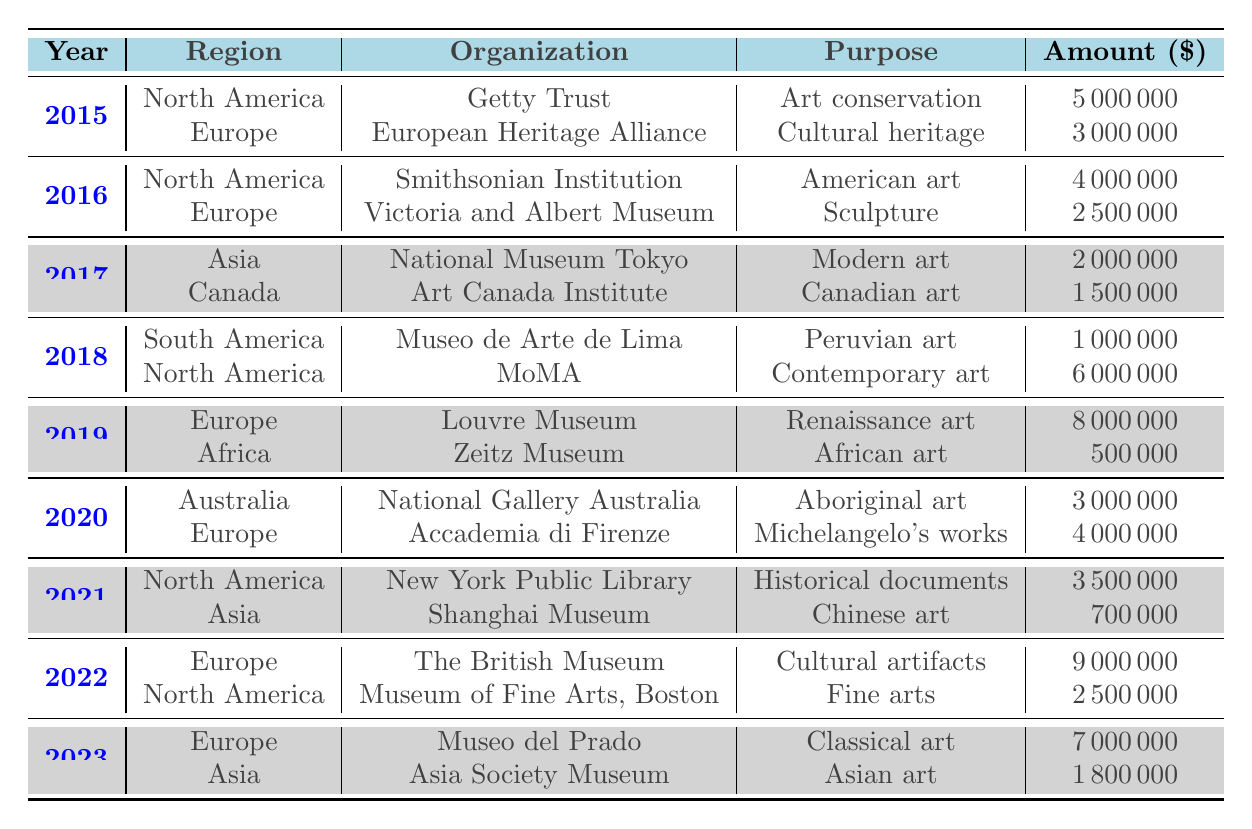What was the total amount donated in 2019? From the table, the donations in 2019 were made to the Louvre Museum for 8,000,000 and to the Zeitz Museum for 500,000. Adding these amounts gives 8,000,000 + 500,000 = 8,500,000.
Answer: 8,500,000 Which organization received the highest donation in 2022? In 2022, the donations were made to The British Museum for 9,000,000 and to The Museum of Fine Arts, Boston for 2,500,000. Comparing these amounts, The British Museum received the highest donation.
Answer: The British Museum How much was donated to art preservation in Europe in 2020? In 2020, the donations to Europe included 4,000,000 to the Accademia di Belle Arti di Firenze. This is the only donation listed for Europe in that year.
Answer: 4,000,000 Which region had the least amount of donations overall? Tracking the total donations per region shows: North America (23,000,000), Europe (26,500,000), Asia (4,700,000), Africa (500,000), South America (1,000,000), and Australia (3,000,000). The least amount was to Africa at 500,000.
Answer: Africa Was there any donation made for the preservation of Michelangelo's works? Yes, in 2020, the Accademia di Belle Arti di Firenze received a donation of 4,000,000 specifically for the preservation of Michelangelo's works.
Answer: Yes What is the total amount donated to North America from 2015 to 2023? The donations from North America are: 5,000,000 (2015), 4,000,000 (2016), 6,000,000 (2018), 3,500,000 (2021), and 2,500,000 (2022). Summing these gives 5,000,000 + 4,000,000 + 6,000,000 + 3,500,000 + 2,500,000 = 21,000,000.
Answer: 21,000,000 In which year were the highest total donations made, and how much were they? Looking at yearly totals: 2015 (8,000,000), 2016 (6,500,000), 2017 (3,500,000), 2018 (7,000,000), 2019 (8,500,000), 2020 (7,000,000), 2021 (4,200,000), 2022 (11,500,000), 2023 (8,500,000). The highest was in 2022 at 11,500,000.
Answer: 2022, 11,500,000 How many different organizations received donations in Asia from 2015 to 2023? The table identifies two organizations in Asia: National Museum of Modern Art, Tokyo in 2017 and Asia Society Museum in 2023. Thus, there are two organizations from Asia listed.
Answer: 2 What was the average amount donated to European organizations from 2015 to 2023? The total donations to Europe over these years (3,000,000 + 2,500,000 + 8,000,000 + 4,000,000 + 9,000,000 + 7,000,000) totals 33,500,000. Dividing this by 6 organizations gives an average of 5,583,333.
Answer: 5,583,333 